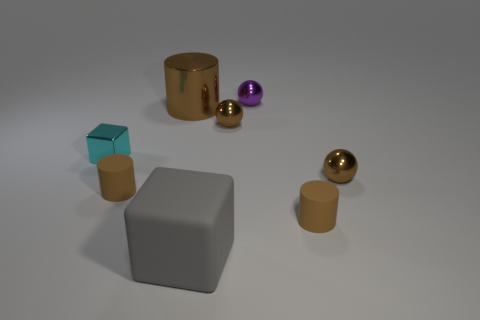Subtract all small cylinders. How many cylinders are left? 1 Subtract 1 spheres. How many spheres are left? 2 Subtract all red cylinders. Subtract all green blocks. How many cylinders are left? 3 Add 1 balls. How many objects exist? 9 Subtract all balls. How many objects are left? 5 Add 3 brown spheres. How many brown spheres are left? 5 Add 5 small metallic spheres. How many small metallic spheres exist? 8 Subtract 0 yellow cylinders. How many objects are left? 8 Subtract all brown spheres. Subtract all small metal things. How many objects are left? 2 